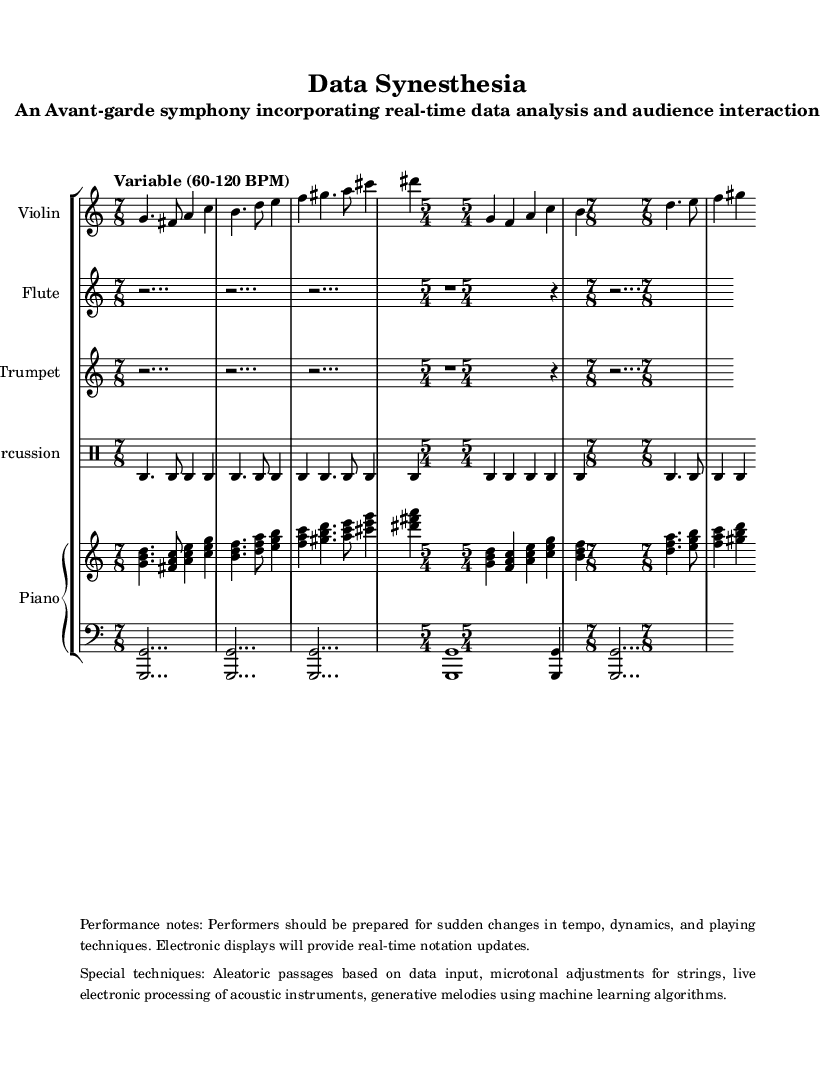What is the key signature of this music? The key signature is C major, which has no sharps or flats indicated in the music. The absence of sharps or flats in the key signature clef confirms it is in C major.
Answer: C major What is the time signature for the majority of the symphony? The majority of the symphony is written in 7/8 time, as indicated on the first staff of the score. Most of the measures are marked by the time signature 7/8.
Answer: 7/8 What is the tempo range specified in the music? The tempo range varies from 60-120 BPM, as noted in the tempo marking at the beginning of the score. This variable tempo reflects the avant-garde style of the piece.
Answer: Variable (60-120 BPM) How many measures are written in 5/4 time? There are two measures in 5/4 time, as indicated by the two instances of the 5/4 time signature in the score. Both instances are found within the Violin, Piano, and Percussion staves.
Answer: 2 What special techniques are mentioned for this performance? The special techniques include aleatoric passages based on data input, which are described in the performance notes included in the markup. This shows the piece utilizes contemporary performance techniques.
Answer: Aleatoric passages What instruments are included in this symphony? The instruments include Violin, Flute, Trumpet, Percussion, and Piano, as specified by the staff grouping at the beginning of the score. Each instrument has its own designated staff in the score.
Answer: Violin, Flute, Trumpet, Percussion, Piano What unique element is incorporated into the performances? Live electronic processing of acoustic instruments is incorporated into the performances, highlighting the interaction between technology and traditional instruments as mentioned in the performance notes.
Answer: Live electronic processing 